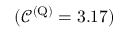<formula> <loc_0><loc_0><loc_500><loc_500>( \ m a t h s c r { C } ^ { ( Q ) } = 3 . 1 7 )</formula> 